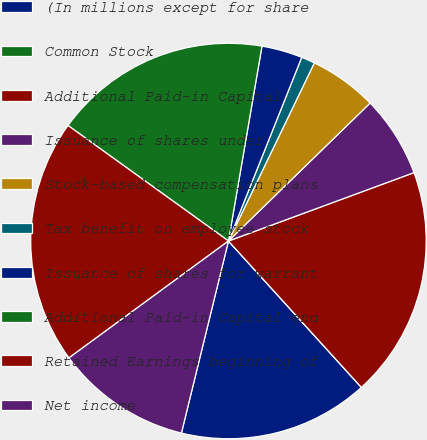Convert chart. <chart><loc_0><loc_0><loc_500><loc_500><pie_chart><fcel>(In millions except for share<fcel>Common Stock<fcel>Additional Paid-in Capital<fcel>Issuance of shares under<fcel>Stock-based compensation plans<fcel>Tax benefit on employee stock<fcel>Issuance of shares for warrant<fcel>Additional Paid-in Capital end<fcel>Retained Earnings beginning of<fcel>Net income<nl><fcel>15.56%<fcel>0.0%<fcel>18.89%<fcel>6.67%<fcel>5.56%<fcel>1.11%<fcel>3.33%<fcel>17.78%<fcel>20.0%<fcel>11.11%<nl></chart> 